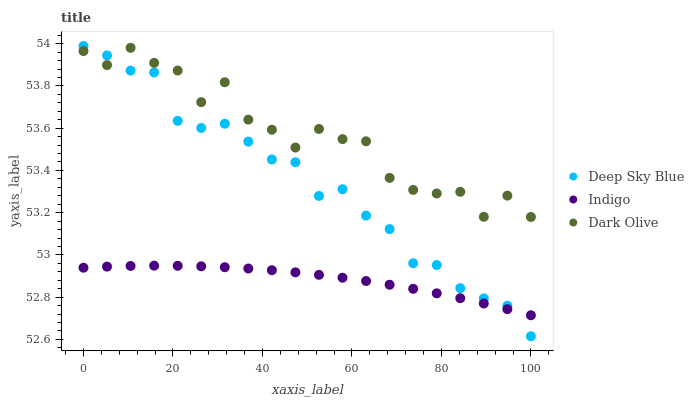Does Indigo have the minimum area under the curve?
Answer yes or no. Yes. Does Dark Olive have the maximum area under the curve?
Answer yes or no. Yes. Does Deep Sky Blue have the minimum area under the curve?
Answer yes or no. No. Does Deep Sky Blue have the maximum area under the curve?
Answer yes or no. No. Is Indigo the smoothest?
Answer yes or no. Yes. Is Dark Olive the roughest?
Answer yes or no. Yes. Is Deep Sky Blue the smoothest?
Answer yes or no. No. Is Deep Sky Blue the roughest?
Answer yes or no. No. Does Deep Sky Blue have the lowest value?
Answer yes or no. Yes. Does Indigo have the lowest value?
Answer yes or no. No. Does Deep Sky Blue have the highest value?
Answer yes or no. Yes. Does Indigo have the highest value?
Answer yes or no. No. Is Indigo less than Dark Olive?
Answer yes or no. Yes. Is Dark Olive greater than Indigo?
Answer yes or no. Yes. Does Indigo intersect Deep Sky Blue?
Answer yes or no. Yes. Is Indigo less than Deep Sky Blue?
Answer yes or no. No. Is Indigo greater than Deep Sky Blue?
Answer yes or no. No. Does Indigo intersect Dark Olive?
Answer yes or no. No. 